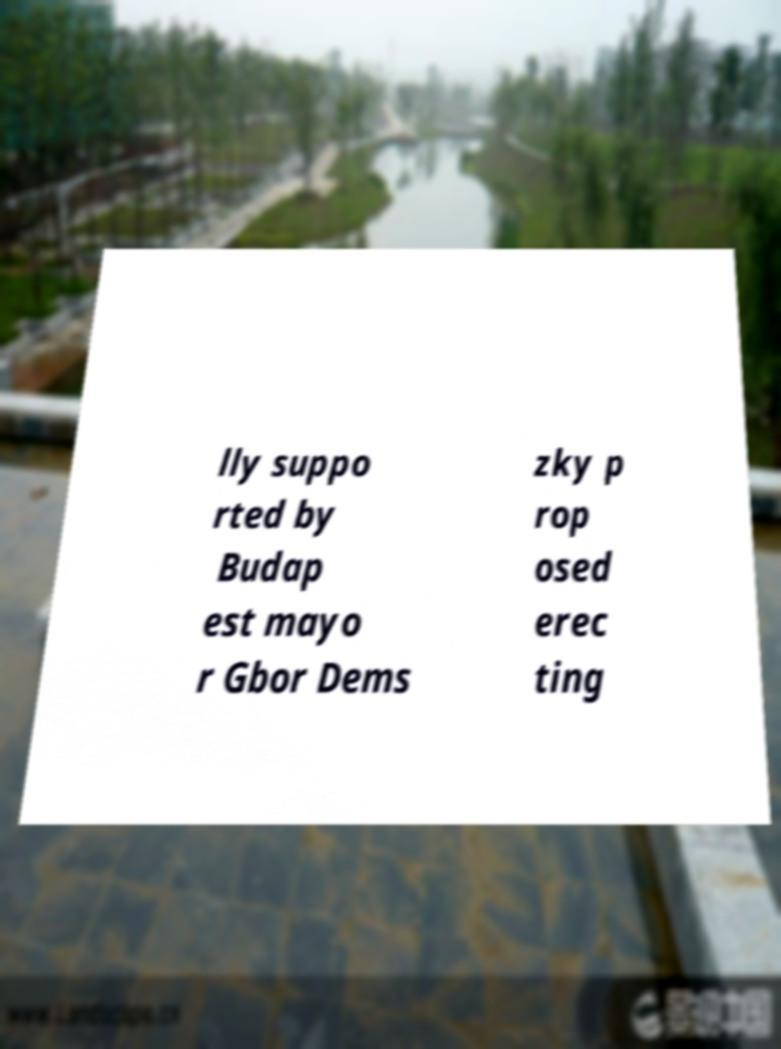Please read and relay the text visible in this image. What does it say? lly suppo rted by Budap est mayo r Gbor Dems zky p rop osed erec ting 